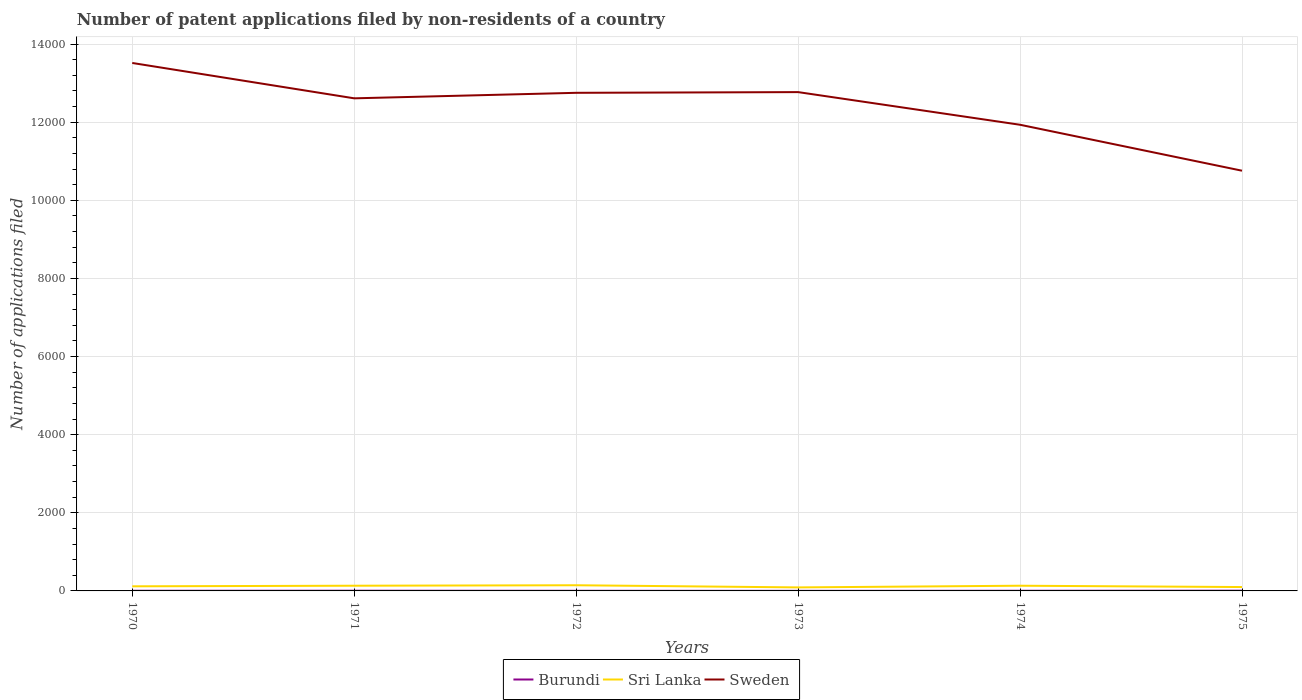Does the line corresponding to Burundi intersect with the line corresponding to Sweden?
Your answer should be compact. No. Across all years, what is the maximum number of applications filed in Sweden?
Ensure brevity in your answer.  1.08e+04. In which year was the number of applications filed in Sweden maximum?
Keep it short and to the point. 1975. What is the total number of applications filed in Sweden in the graph?
Offer a terse response. 2758. What is the difference between the highest and the second highest number of applications filed in Sweden?
Keep it short and to the point. 2758. What is the difference between the highest and the lowest number of applications filed in Burundi?
Ensure brevity in your answer.  2. How many lines are there?
Your answer should be very brief. 3. How many years are there in the graph?
Your response must be concise. 6. What is the difference between two consecutive major ticks on the Y-axis?
Offer a terse response. 2000. Where does the legend appear in the graph?
Your answer should be compact. Bottom center. How many legend labels are there?
Offer a terse response. 3. What is the title of the graph?
Offer a very short reply. Number of patent applications filed by non-residents of a country. Does "Turkey" appear as one of the legend labels in the graph?
Keep it short and to the point. No. What is the label or title of the X-axis?
Your answer should be very brief. Years. What is the label or title of the Y-axis?
Your answer should be compact. Number of applications filed. What is the Number of applications filed of Sri Lanka in 1970?
Keep it short and to the point. 118. What is the Number of applications filed in Sweden in 1970?
Offer a very short reply. 1.35e+04. What is the Number of applications filed of Sri Lanka in 1971?
Your response must be concise. 133. What is the Number of applications filed of Sweden in 1971?
Provide a short and direct response. 1.26e+04. What is the Number of applications filed of Burundi in 1972?
Offer a terse response. 3. What is the Number of applications filed of Sri Lanka in 1972?
Your answer should be compact. 145. What is the Number of applications filed in Sweden in 1972?
Offer a very short reply. 1.28e+04. What is the Number of applications filed of Sri Lanka in 1973?
Provide a short and direct response. 90. What is the Number of applications filed of Sweden in 1973?
Give a very brief answer. 1.28e+04. What is the Number of applications filed of Sri Lanka in 1974?
Make the answer very short. 133. What is the Number of applications filed of Sweden in 1974?
Provide a short and direct response. 1.19e+04. What is the Number of applications filed in Sri Lanka in 1975?
Provide a succinct answer. 99. What is the Number of applications filed in Sweden in 1975?
Your answer should be compact. 1.08e+04. Across all years, what is the maximum Number of applications filed of Burundi?
Provide a succinct answer. 6. Across all years, what is the maximum Number of applications filed of Sri Lanka?
Ensure brevity in your answer.  145. Across all years, what is the maximum Number of applications filed in Sweden?
Make the answer very short. 1.35e+04. Across all years, what is the minimum Number of applications filed in Burundi?
Give a very brief answer. 2. Across all years, what is the minimum Number of applications filed of Sri Lanka?
Offer a very short reply. 90. Across all years, what is the minimum Number of applications filed of Sweden?
Offer a very short reply. 1.08e+04. What is the total Number of applications filed of Burundi in the graph?
Your response must be concise. 24. What is the total Number of applications filed of Sri Lanka in the graph?
Your answer should be compact. 718. What is the total Number of applications filed of Sweden in the graph?
Offer a very short reply. 7.43e+04. What is the difference between the Number of applications filed in Sweden in 1970 and that in 1971?
Keep it short and to the point. 905. What is the difference between the Number of applications filed of Sri Lanka in 1970 and that in 1972?
Offer a terse response. -27. What is the difference between the Number of applications filed of Sweden in 1970 and that in 1972?
Make the answer very short. 764. What is the difference between the Number of applications filed of Sri Lanka in 1970 and that in 1973?
Make the answer very short. 28. What is the difference between the Number of applications filed of Sweden in 1970 and that in 1973?
Ensure brevity in your answer.  746. What is the difference between the Number of applications filed of Burundi in 1970 and that in 1974?
Provide a short and direct response. 0. What is the difference between the Number of applications filed in Sweden in 1970 and that in 1974?
Ensure brevity in your answer.  1582. What is the difference between the Number of applications filed in Sweden in 1970 and that in 1975?
Your response must be concise. 2758. What is the difference between the Number of applications filed of Burundi in 1971 and that in 1972?
Give a very brief answer. 2. What is the difference between the Number of applications filed of Sweden in 1971 and that in 1972?
Give a very brief answer. -141. What is the difference between the Number of applications filed in Sweden in 1971 and that in 1973?
Make the answer very short. -159. What is the difference between the Number of applications filed in Burundi in 1971 and that in 1974?
Your response must be concise. 1. What is the difference between the Number of applications filed of Sri Lanka in 1971 and that in 1974?
Ensure brevity in your answer.  0. What is the difference between the Number of applications filed in Sweden in 1971 and that in 1974?
Keep it short and to the point. 677. What is the difference between the Number of applications filed of Sweden in 1971 and that in 1975?
Your answer should be very brief. 1853. What is the difference between the Number of applications filed of Burundi in 1972 and that in 1973?
Make the answer very short. 1. What is the difference between the Number of applications filed of Sweden in 1972 and that in 1973?
Your response must be concise. -18. What is the difference between the Number of applications filed of Sweden in 1972 and that in 1974?
Your answer should be very brief. 818. What is the difference between the Number of applications filed of Sri Lanka in 1972 and that in 1975?
Give a very brief answer. 46. What is the difference between the Number of applications filed of Sweden in 1972 and that in 1975?
Provide a succinct answer. 1994. What is the difference between the Number of applications filed of Burundi in 1973 and that in 1974?
Your answer should be compact. -2. What is the difference between the Number of applications filed of Sri Lanka in 1973 and that in 1974?
Ensure brevity in your answer.  -43. What is the difference between the Number of applications filed in Sweden in 1973 and that in 1974?
Your answer should be compact. 836. What is the difference between the Number of applications filed of Burundi in 1973 and that in 1975?
Your response must be concise. -4. What is the difference between the Number of applications filed in Sri Lanka in 1973 and that in 1975?
Keep it short and to the point. -9. What is the difference between the Number of applications filed of Sweden in 1973 and that in 1975?
Provide a short and direct response. 2012. What is the difference between the Number of applications filed of Burundi in 1974 and that in 1975?
Your response must be concise. -2. What is the difference between the Number of applications filed of Sri Lanka in 1974 and that in 1975?
Provide a short and direct response. 34. What is the difference between the Number of applications filed of Sweden in 1974 and that in 1975?
Your answer should be very brief. 1176. What is the difference between the Number of applications filed in Burundi in 1970 and the Number of applications filed in Sri Lanka in 1971?
Keep it short and to the point. -129. What is the difference between the Number of applications filed of Burundi in 1970 and the Number of applications filed of Sweden in 1971?
Make the answer very short. -1.26e+04. What is the difference between the Number of applications filed in Sri Lanka in 1970 and the Number of applications filed in Sweden in 1971?
Offer a terse response. -1.25e+04. What is the difference between the Number of applications filed in Burundi in 1970 and the Number of applications filed in Sri Lanka in 1972?
Your response must be concise. -141. What is the difference between the Number of applications filed of Burundi in 1970 and the Number of applications filed of Sweden in 1972?
Give a very brief answer. -1.27e+04. What is the difference between the Number of applications filed in Sri Lanka in 1970 and the Number of applications filed in Sweden in 1972?
Give a very brief answer. -1.26e+04. What is the difference between the Number of applications filed of Burundi in 1970 and the Number of applications filed of Sri Lanka in 1973?
Provide a short and direct response. -86. What is the difference between the Number of applications filed of Burundi in 1970 and the Number of applications filed of Sweden in 1973?
Provide a short and direct response. -1.28e+04. What is the difference between the Number of applications filed of Sri Lanka in 1970 and the Number of applications filed of Sweden in 1973?
Your response must be concise. -1.27e+04. What is the difference between the Number of applications filed of Burundi in 1970 and the Number of applications filed of Sri Lanka in 1974?
Offer a terse response. -129. What is the difference between the Number of applications filed of Burundi in 1970 and the Number of applications filed of Sweden in 1974?
Make the answer very short. -1.19e+04. What is the difference between the Number of applications filed of Sri Lanka in 1970 and the Number of applications filed of Sweden in 1974?
Keep it short and to the point. -1.18e+04. What is the difference between the Number of applications filed in Burundi in 1970 and the Number of applications filed in Sri Lanka in 1975?
Offer a very short reply. -95. What is the difference between the Number of applications filed in Burundi in 1970 and the Number of applications filed in Sweden in 1975?
Offer a very short reply. -1.08e+04. What is the difference between the Number of applications filed in Sri Lanka in 1970 and the Number of applications filed in Sweden in 1975?
Your answer should be very brief. -1.06e+04. What is the difference between the Number of applications filed of Burundi in 1971 and the Number of applications filed of Sri Lanka in 1972?
Offer a very short reply. -140. What is the difference between the Number of applications filed in Burundi in 1971 and the Number of applications filed in Sweden in 1972?
Your answer should be compact. -1.27e+04. What is the difference between the Number of applications filed of Sri Lanka in 1971 and the Number of applications filed of Sweden in 1972?
Provide a short and direct response. -1.26e+04. What is the difference between the Number of applications filed of Burundi in 1971 and the Number of applications filed of Sri Lanka in 1973?
Offer a very short reply. -85. What is the difference between the Number of applications filed in Burundi in 1971 and the Number of applications filed in Sweden in 1973?
Keep it short and to the point. -1.28e+04. What is the difference between the Number of applications filed in Sri Lanka in 1971 and the Number of applications filed in Sweden in 1973?
Offer a terse response. -1.26e+04. What is the difference between the Number of applications filed of Burundi in 1971 and the Number of applications filed of Sri Lanka in 1974?
Give a very brief answer. -128. What is the difference between the Number of applications filed of Burundi in 1971 and the Number of applications filed of Sweden in 1974?
Give a very brief answer. -1.19e+04. What is the difference between the Number of applications filed of Sri Lanka in 1971 and the Number of applications filed of Sweden in 1974?
Offer a very short reply. -1.18e+04. What is the difference between the Number of applications filed of Burundi in 1971 and the Number of applications filed of Sri Lanka in 1975?
Ensure brevity in your answer.  -94. What is the difference between the Number of applications filed of Burundi in 1971 and the Number of applications filed of Sweden in 1975?
Make the answer very short. -1.08e+04. What is the difference between the Number of applications filed of Sri Lanka in 1971 and the Number of applications filed of Sweden in 1975?
Keep it short and to the point. -1.06e+04. What is the difference between the Number of applications filed of Burundi in 1972 and the Number of applications filed of Sri Lanka in 1973?
Your answer should be very brief. -87. What is the difference between the Number of applications filed in Burundi in 1972 and the Number of applications filed in Sweden in 1973?
Offer a very short reply. -1.28e+04. What is the difference between the Number of applications filed in Sri Lanka in 1972 and the Number of applications filed in Sweden in 1973?
Your response must be concise. -1.26e+04. What is the difference between the Number of applications filed in Burundi in 1972 and the Number of applications filed in Sri Lanka in 1974?
Your answer should be compact. -130. What is the difference between the Number of applications filed of Burundi in 1972 and the Number of applications filed of Sweden in 1974?
Your answer should be compact. -1.19e+04. What is the difference between the Number of applications filed in Sri Lanka in 1972 and the Number of applications filed in Sweden in 1974?
Provide a short and direct response. -1.18e+04. What is the difference between the Number of applications filed in Burundi in 1972 and the Number of applications filed in Sri Lanka in 1975?
Make the answer very short. -96. What is the difference between the Number of applications filed of Burundi in 1972 and the Number of applications filed of Sweden in 1975?
Your answer should be compact. -1.08e+04. What is the difference between the Number of applications filed of Sri Lanka in 1972 and the Number of applications filed of Sweden in 1975?
Keep it short and to the point. -1.06e+04. What is the difference between the Number of applications filed in Burundi in 1973 and the Number of applications filed in Sri Lanka in 1974?
Provide a succinct answer. -131. What is the difference between the Number of applications filed of Burundi in 1973 and the Number of applications filed of Sweden in 1974?
Offer a very short reply. -1.19e+04. What is the difference between the Number of applications filed in Sri Lanka in 1973 and the Number of applications filed in Sweden in 1974?
Offer a terse response. -1.18e+04. What is the difference between the Number of applications filed in Burundi in 1973 and the Number of applications filed in Sri Lanka in 1975?
Ensure brevity in your answer.  -97. What is the difference between the Number of applications filed in Burundi in 1973 and the Number of applications filed in Sweden in 1975?
Keep it short and to the point. -1.08e+04. What is the difference between the Number of applications filed of Sri Lanka in 1973 and the Number of applications filed of Sweden in 1975?
Make the answer very short. -1.07e+04. What is the difference between the Number of applications filed of Burundi in 1974 and the Number of applications filed of Sri Lanka in 1975?
Your response must be concise. -95. What is the difference between the Number of applications filed of Burundi in 1974 and the Number of applications filed of Sweden in 1975?
Provide a succinct answer. -1.08e+04. What is the difference between the Number of applications filed of Sri Lanka in 1974 and the Number of applications filed of Sweden in 1975?
Keep it short and to the point. -1.06e+04. What is the average Number of applications filed of Burundi per year?
Keep it short and to the point. 4. What is the average Number of applications filed in Sri Lanka per year?
Provide a short and direct response. 119.67. What is the average Number of applications filed of Sweden per year?
Offer a terse response. 1.24e+04. In the year 1970, what is the difference between the Number of applications filed of Burundi and Number of applications filed of Sri Lanka?
Provide a short and direct response. -114. In the year 1970, what is the difference between the Number of applications filed in Burundi and Number of applications filed in Sweden?
Provide a short and direct response. -1.35e+04. In the year 1970, what is the difference between the Number of applications filed of Sri Lanka and Number of applications filed of Sweden?
Provide a succinct answer. -1.34e+04. In the year 1971, what is the difference between the Number of applications filed of Burundi and Number of applications filed of Sri Lanka?
Your answer should be very brief. -128. In the year 1971, what is the difference between the Number of applications filed in Burundi and Number of applications filed in Sweden?
Offer a terse response. -1.26e+04. In the year 1971, what is the difference between the Number of applications filed in Sri Lanka and Number of applications filed in Sweden?
Ensure brevity in your answer.  -1.25e+04. In the year 1972, what is the difference between the Number of applications filed of Burundi and Number of applications filed of Sri Lanka?
Provide a succinct answer. -142. In the year 1972, what is the difference between the Number of applications filed of Burundi and Number of applications filed of Sweden?
Provide a succinct answer. -1.27e+04. In the year 1972, what is the difference between the Number of applications filed of Sri Lanka and Number of applications filed of Sweden?
Provide a succinct answer. -1.26e+04. In the year 1973, what is the difference between the Number of applications filed of Burundi and Number of applications filed of Sri Lanka?
Your answer should be very brief. -88. In the year 1973, what is the difference between the Number of applications filed of Burundi and Number of applications filed of Sweden?
Offer a very short reply. -1.28e+04. In the year 1973, what is the difference between the Number of applications filed of Sri Lanka and Number of applications filed of Sweden?
Make the answer very short. -1.27e+04. In the year 1974, what is the difference between the Number of applications filed of Burundi and Number of applications filed of Sri Lanka?
Ensure brevity in your answer.  -129. In the year 1974, what is the difference between the Number of applications filed of Burundi and Number of applications filed of Sweden?
Give a very brief answer. -1.19e+04. In the year 1974, what is the difference between the Number of applications filed in Sri Lanka and Number of applications filed in Sweden?
Your answer should be compact. -1.18e+04. In the year 1975, what is the difference between the Number of applications filed in Burundi and Number of applications filed in Sri Lanka?
Ensure brevity in your answer.  -93. In the year 1975, what is the difference between the Number of applications filed of Burundi and Number of applications filed of Sweden?
Your answer should be very brief. -1.08e+04. In the year 1975, what is the difference between the Number of applications filed of Sri Lanka and Number of applications filed of Sweden?
Keep it short and to the point. -1.07e+04. What is the ratio of the Number of applications filed in Burundi in 1970 to that in 1971?
Keep it short and to the point. 0.8. What is the ratio of the Number of applications filed in Sri Lanka in 1970 to that in 1971?
Provide a succinct answer. 0.89. What is the ratio of the Number of applications filed in Sweden in 1970 to that in 1971?
Give a very brief answer. 1.07. What is the ratio of the Number of applications filed in Sri Lanka in 1970 to that in 1972?
Keep it short and to the point. 0.81. What is the ratio of the Number of applications filed of Sweden in 1970 to that in 1972?
Offer a terse response. 1.06. What is the ratio of the Number of applications filed in Burundi in 1970 to that in 1973?
Ensure brevity in your answer.  2. What is the ratio of the Number of applications filed of Sri Lanka in 1970 to that in 1973?
Provide a succinct answer. 1.31. What is the ratio of the Number of applications filed in Sweden in 1970 to that in 1973?
Make the answer very short. 1.06. What is the ratio of the Number of applications filed of Sri Lanka in 1970 to that in 1974?
Your answer should be compact. 0.89. What is the ratio of the Number of applications filed of Sweden in 1970 to that in 1974?
Your answer should be very brief. 1.13. What is the ratio of the Number of applications filed of Burundi in 1970 to that in 1975?
Your response must be concise. 0.67. What is the ratio of the Number of applications filed in Sri Lanka in 1970 to that in 1975?
Offer a terse response. 1.19. What is the ratio of the Number of applications filed in Sweden in 1970 to that in 1975?
Offer a terse response. 1.26. What is the ratio of the Number of applications filed of Sri Lanka in 1971 to that in 1972?
Give a very brief answer. 0.92. What is the ratio of the Number of applications filed of Sweden in 1971 to that in 1972?
Give a very brief answer. 0.99. What is the ratio of the Number of applications filed in Sri Lanka in 1971 to that in 1973?
Give a very brief answer. 1.48. What is the ratio of the Number of applications filed of Sweden in 1971 to that in 1973?
Keep it short and to the point. 0.99. What is the ratio of the Number of applications filed in Sweden in 1971 to that in 1974?
Make the answer very short. 1.06. What is the ratio of the Number of applications filed of Burundi in 1971 to that in 1975?
Provide a succinct answer. 0.83. What is the ratio of the Number of applications filed of Sri Lanka in 1971 to that in 1975?
Provide a succinct answer. 1.34. What is the ratio of the Number of applications filed of Sweden in 1971 to that in 1975?
Your answer should be very brief. 1.17. What is the ratio of the Number of applications filed in Sri Lanka in 1972 to that in 1973?
Ensure brevity in your answer.  1.61. What is the ratio of the Number of applications filed of Sweden in 1972 to that in 1973?
Give a very brief answer. 1. What is the ratio of the Number of applications filed of Burundi in 1972 to that in 1974?
Make the answer very short. 0.75. What is the ratio of the Number of applications filed in Sri Lanka in 1972 to that in 1974?
Your response must be concise. 1.09. What is the ratio of the Number of applications filed of Sweden in 1972 to that in 1974?
Ensure brevity in your answer.  1.07. What is the ratio of the Number of applications filed of Sri Lanka in 1972 to that in 1975?
Offer a terse response. 1.46. What is the ratio of the Number of applications filed of Sweden in 1972 to that in 1975?
Provide a short and direct response. 1.19. What is the ratio of the Number of applications filed in Burundi in 1973 to that in 1974?
Provide a short and direct response. 0.5. What is the ratio of the Number of applications filed of Sri Lanka in 1973 to that in 1974?
Provide a succinct answer. 0.68. What is the ratio of the Number of applications filed in Sweden in 1973 to that in 1974?
Your answer should be very brief. 1.07. What is the ratio of the Number of applications filed in Burundi in 1973 to that in 1975?
Your answer should be compact. 0.33. What is the ratio of the Number of applications filed of Sweden in 1973 to that in 1975?
Ensure brevity in your answer.  1.19. What is the ratio of the Number of applications filed in Burundi in 1974 to that in 1975?
Provide a short and direct response. 0.67. What is the ratio of the Number of applications filed in Sri Lanka in 1974 to that in 1975?
Make the answer very short. 1.34. What is the ratio of the Number of applications filed of Sweden in 1974 to that in 1975?
Your answer should be very brief. 1.11. What is the difference between the highest and the second highest Number of applications filed in Sri Lanka?
Provide a short and direct response. 12. What is the difference between the highest and the second highest Number of applications filed of Sweden?
Give a very brief answer. 746. What is the difference between the highest and the lowest Number of applications filed in Burundi?
Make the answer very short. 4. What is the difference between the highest and the lowest Number of applications filed of Sri Lanka?
Keep it short and to the point. 55. What is the difference between the highest and the lowest Number of applications filed in Sweden?
Your response must be concise. 2758. 